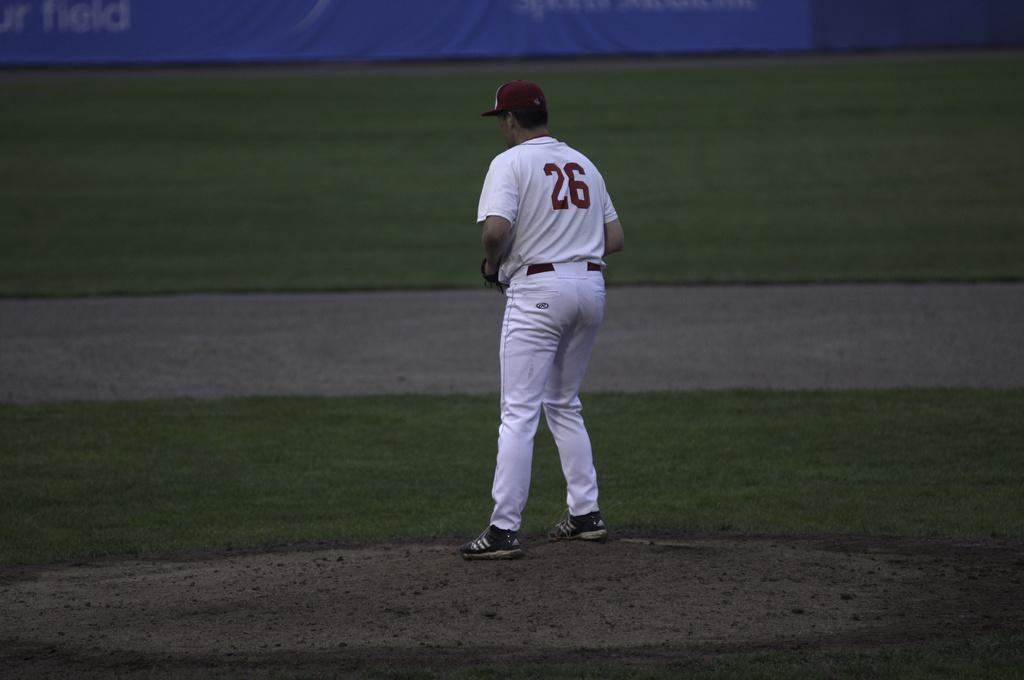<image>
Summarize the visual content of the image. Player number 26 is standing on the pitcher's mound. 